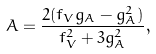Convert formula to latex. <formula><loc_0><loc_0><loc_500><loc_500>A = \frac { 2 ( f _ { V } g _ { A } - g _ { A } ^ { 2 } ) } { f _ { V } ^ { 2 } + 3 g _ { A } ^ { 2 } } ,</formula> 